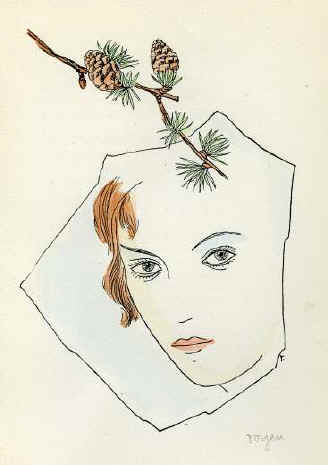Can you elaborate on the elements of the picture provided? The image features a striking rendition of a woman in a minimalist, surrealist style. Her facial features are sketched with graceful, fluid lines that highlight her contemplative expression. Her cheeks and lips are touched with a soft rose hue, injecting a life-like quality into the sketch. Intriguingly, a branch with pine cones adorns her head, merging nature with human form, a typical surrealistic technique that evokes thought about human connection with nature. The beige background serves not just as a neutral canvas but subtly enforces the focus on the central figure and her unusual adornment. This artwork may suggest themes of growth and the natural cycle, symbolically using the pine cones, which are often associated with regeneration. 